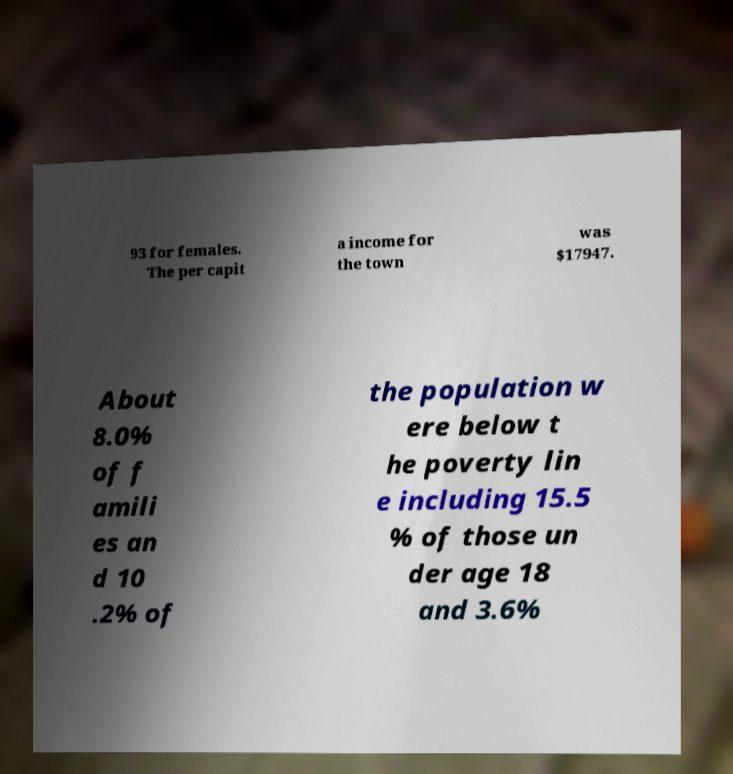Could you assist in decoding the text presented in this image and type it out clearly? 93 for females. The per capit a income for the town was $17947. About 8.0% of f amili es an d 10 .2% of the population w ere below t he poverty lin e including 15.5 % of those un der age 18 and 3.6% 